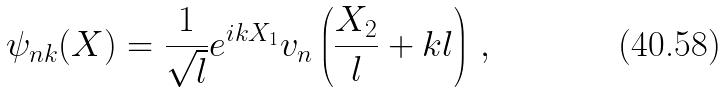<formula> <loc_0><loc_0><loc_500><loc_500>\psi _ { n k } ( X ) = \frac { 1 } { \sqrt { l } } e ^ { i k X _ { 1 } } v _ { n } \left ( \frac { X _ { 2 } } { l } + k l \right ) \, ,</formula> 